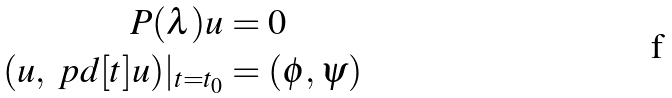<formula> <loc_0><loc_0><loc_500><loc_500>P ( \lambda ) u & = 0 \\ ( u , \ p d [ t ] u ) | _ { t = t _ { 0 } } & = ( \phi , \psi )</formula> 